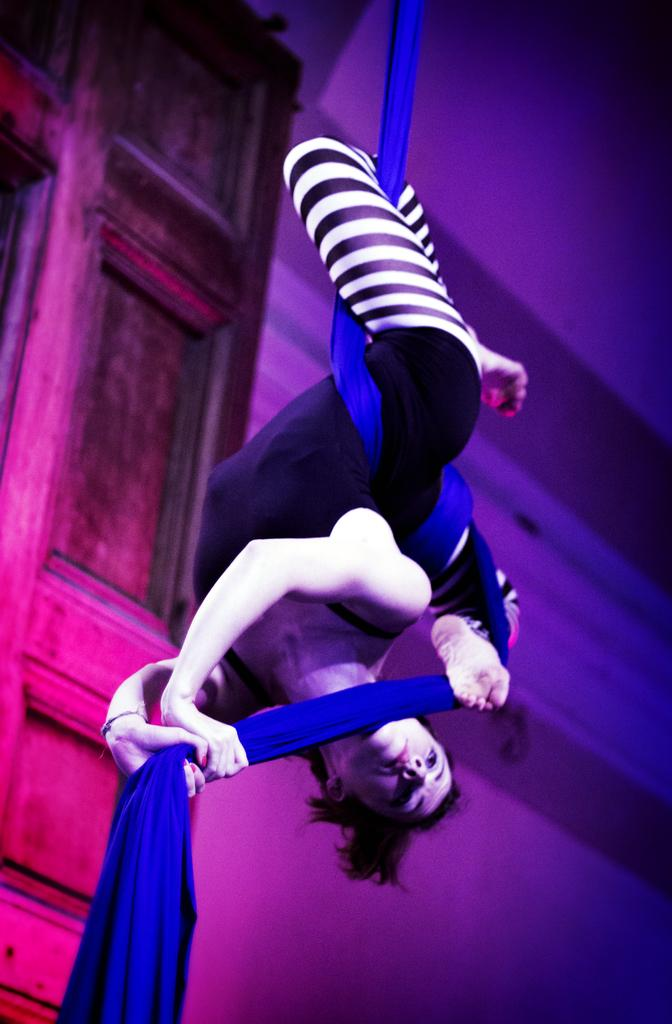Who is the main subject in the image? There is a woman in the image. What is the woman holding in the image? The woman is holding a cloth. What can be seen in the background of the image? There is a door and a wall in the background of the image. Reasoning: Let' Let's think step by step in order to produce the conversation. We start by identifying the main subject in the image, which is the woman. Then, we describe what the woman is holding, which is a cloth. Finally, we mention the background elements, which are a door and a wall. Each question is designed to elicit a specific detail about the image that is known from the provided facts. Absurd Question/Answer: How much was the payment for the box in the image? There is no box or payment mentioned in the image; it only features a woman holding a cloth with a door and a wall in the background. What type of box is being used to store the front in the image? There is no box or front mentioned in the image; it only features a woman holding a cloth with a door and a wall in the background. 